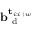Convert formula to latex. <formula><loc_0><loc_0><loc_500><loc_500>b _ { d } ^ { t _ { i \colon i + w } }</formula> 